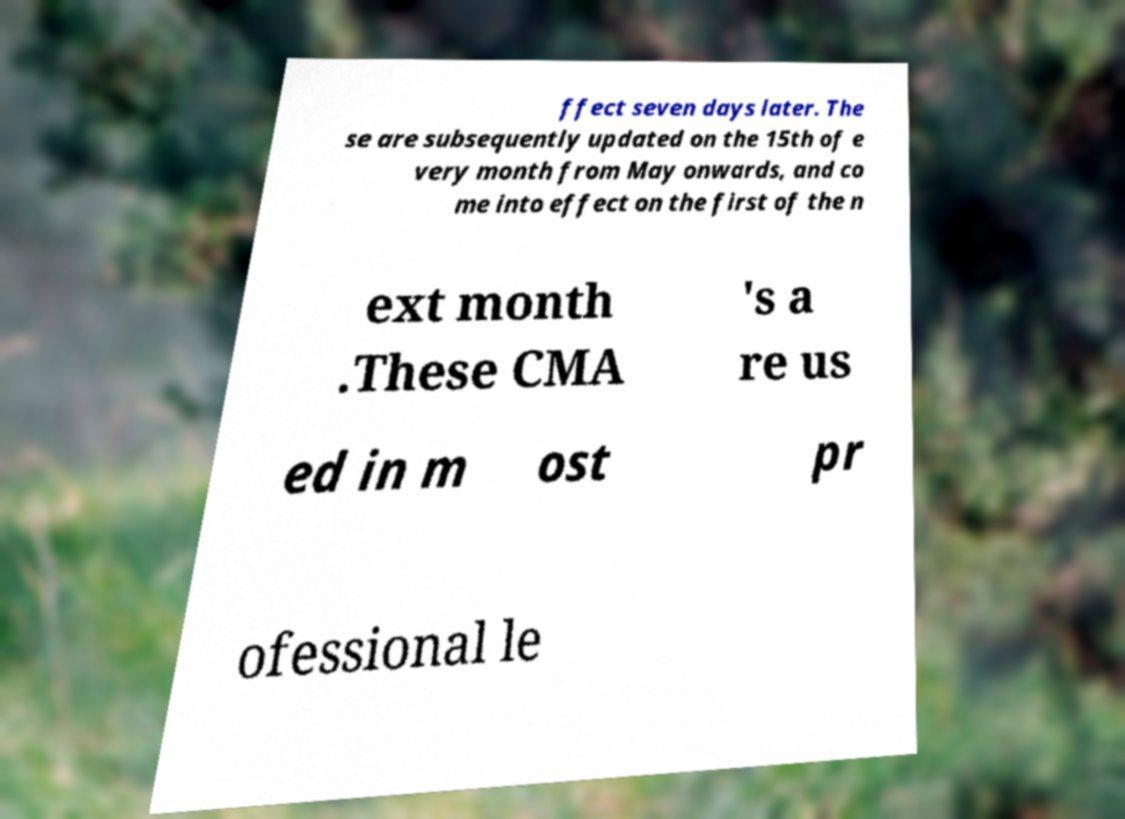Please read and relay the text visible in this image. What does it say? ffect seven days later. The se are subsequently updated on the 15th of e very month from May onwards, and co me into effect on the first of the n ext month .These CMA 's a re us ed in m ost pr ofessional le 